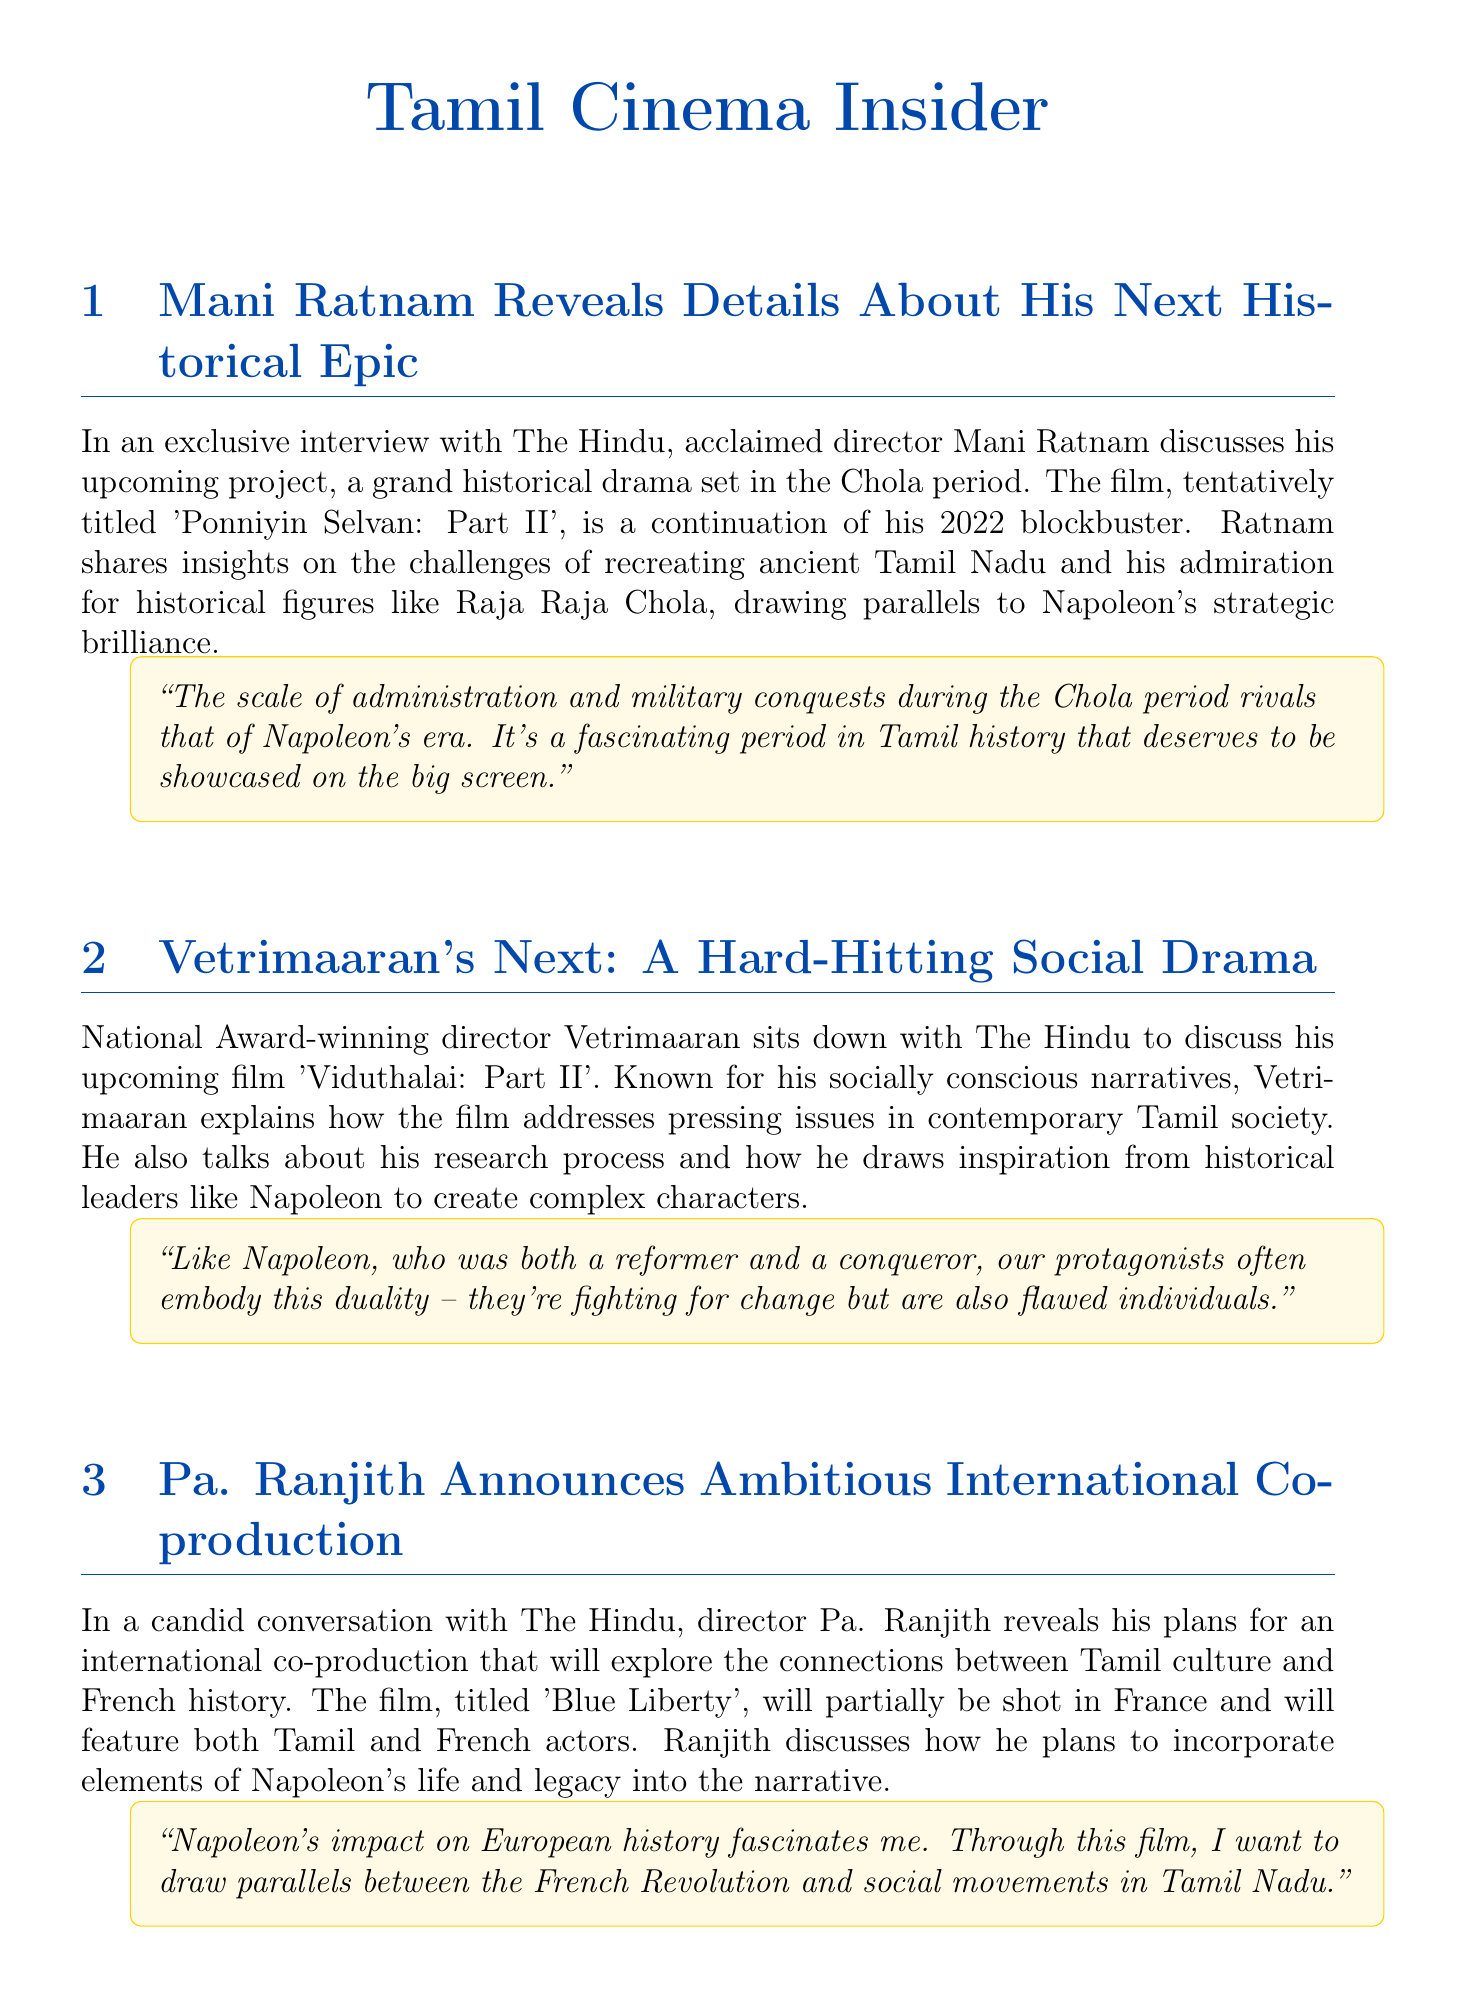What is the title of Mani Ratnam's upcoming film? The title is mentioned as 'Ponniyin Selvan: Part II' in the document.
Answer: 'Ponniyin Selvan: Part II' Who is directing 'Viduthalai: Part II'? The document states that Vetrimaaran is the director of this film.
Answer: Vetrimaaran What historical period does Mani Ratnam's film focus on? The document refers to the Chola period as the historical setting for Ratnam's film.
Answer: Chola period Which social issue is Vetrimaaran's 'Viduthalai: Part II' addressing? The document indicates that the film addresses pressing issues in contemporary Tamil society.
Answer: Pressing issues in contemporary Tamil society What is the title of Pa. Ranjith's upcoming film? The document names the film as 'Blue Liberty'.
Answer: 'Blue Liberty' Which genre is Karthik Subbaraj's film 'Mandate'? The document categorizes 'Mandate' as a political thriller.
Answer: Political thriller Which sport is central to Sudha Kongara's film 'Veerangana'? The document states that the sport featured in the film is kabaddi.
Answer: Kabaddi How does Sudha Kongara draw inspiration from Napoleon? The document mentions that she draws inspiration from Napoleon's strategic thinking for choreographing game sequences.
Answer: Napoleon's strategic thinking What aspect of Napoleon's legacy is explored in Pa. Ranjith's project? The document shows that Ranjith plans to incorporate elements of Napoleon's life and legacy.
Answer: Napoleon's life and legacy 